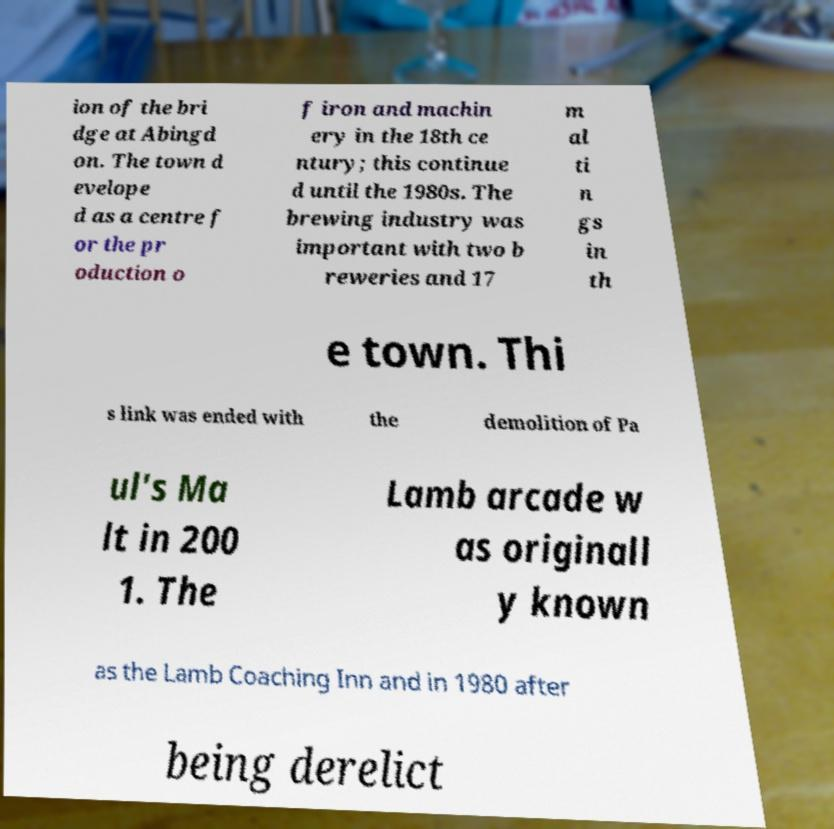Can you accurately transcribe the text from the provided image for me? ion of the bri dge at Abingd on. The town d evelope d as a centre f or the pr oduction o f iron and machin ery in the 18th ce ntury; this continue d until the 1980s. The brewing industry was important with two b reweries and 17 m al ti n gs in th e town. Thi s link was ended with the demolition of Pa ul's Ma lt in 200 1. The Lamb arcade w as originall y known as the Lamb Coaching Inn and in 1980 after being derelict 